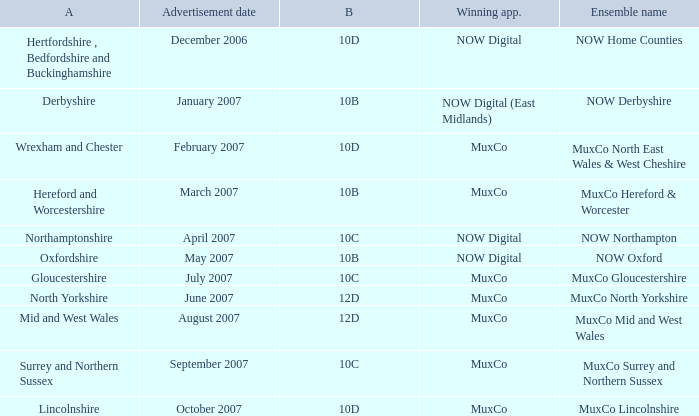What is Ensemble Name Muxco Gloucestershire's Advertisement Date in Block 10C? July 2007. 